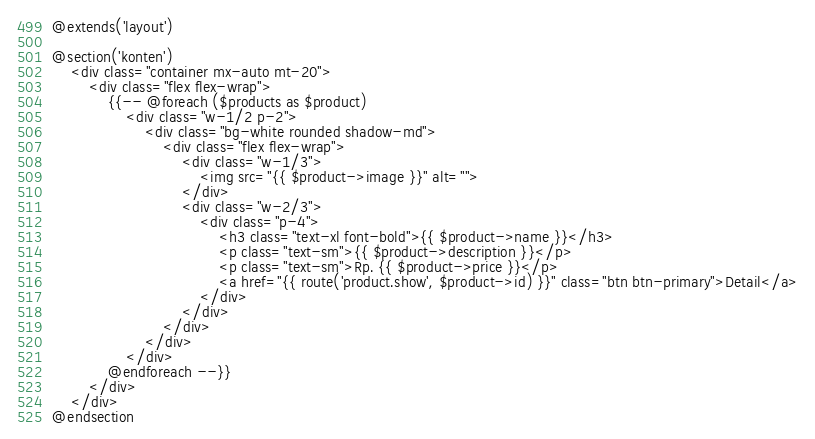Convert code to text. <code><loc_0><loc_0><loc_500><loc_500><_PHP_>@extends('layout')

@section('konten')
    <div class="container mx-auto mt-20">
        <div class="flex flex-wrap">
            {{-- @foreach ($products as $product)
                <div class="w-1/2 p-2">
                    <div class="bg-white rounded shadow-md">
                        <div class="flex flex-wrap">
                            <div class="w-1/3">
                                <img src="{{ $product->image }}" alt="">
                            </div>
                            <div class="w-2/3">
                                <div class="p-4">
                                    <h3 class="text-xl font-bold">{{ $product->name }}</h3>
                                    <p class="text-sm">{{ $product->description }}</p>
                                    <p class="text-sm">Rp. {{ $product->price }}</p>
                                    <a href="{{ route('product.show', $product->id) }}" class="btn btn-primary">Detail</a>
                                </div>
                            </div>
                        </div>
                    </div>
                </div>
            @endforeach --}}
        </div>
    </div>
@endsection</code> 